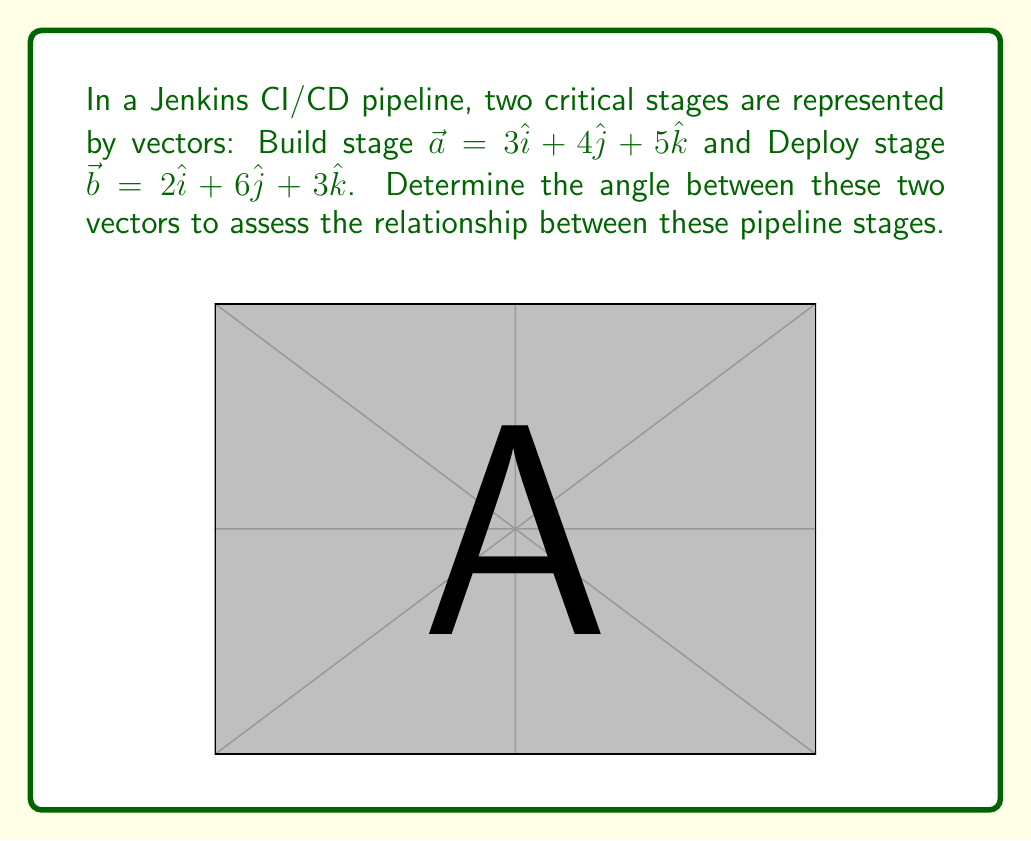Teach me how to tackle this problem. To find the angle between two vectors, we can use the dot product formula:

$$\cos \theta = \frac{\vec{a} \cdot \vec{b}}{|\vec{a}||\vec{b}|}$$

Step 1: Calculate the dot product $\vec{a} \cdot \vec{b}$
$$\vec{a} \cdot \vec{b} = (3)(2) + (4)(6) + (5)(3) = 6 + 24 + 15 = 45$$

Step 2: Calculate the magnitudes of $\vec{a}$ and $\vec{b}$
$$|\vec{a}| = \sqrt{3^2 + 4^2 + 5^2} = \sqrt{50}$$
$$|\vec{b}| = \sqrt{2^2 + 6^2 + 3^2} = \sqrt{49} = 7$$

Step 3: Substitute into the formula
$$\cos \theta = \frac{45}{\sqrt{50} \cdot 7}$$

Step 4: Simplify
$$\cos \theta = \frac{45}{7\sqrt{50}} = \frac{45}{7\sqrt{2} \cdot 5\sqrt{2}} = \frac{9}{14\sqrt{2}}$$

Step 5: Take the inverse cosine (arccos) of both sides
$$\theta = \arccos\left(\frac{9}{14\sqrt{2}}\right)$$

Step 6: Calculate the result (rounded to 2 decimal places)
$$\theta \approx 0.96 \text{ radians} \approx 55.15°$$
Answer: $55.15°$ 